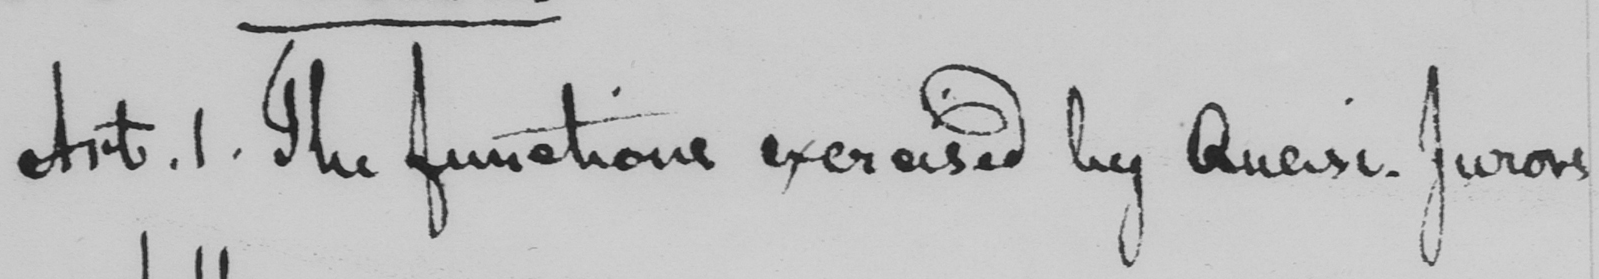Can you read and transcribe this handwriting? Art . 1 . The functions exercised by Quasi-Jurors 